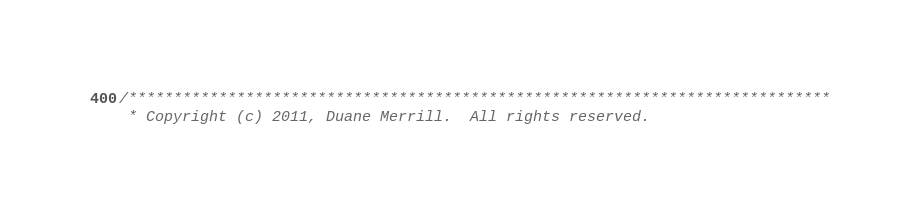Convert code to text. <code><loc_0><loc_0><loc_500><loc_500><_Cuda_>/******************************************************************************
 * Copyright (c) 2011, Duane Merrill.  All rights reserved.</code> 